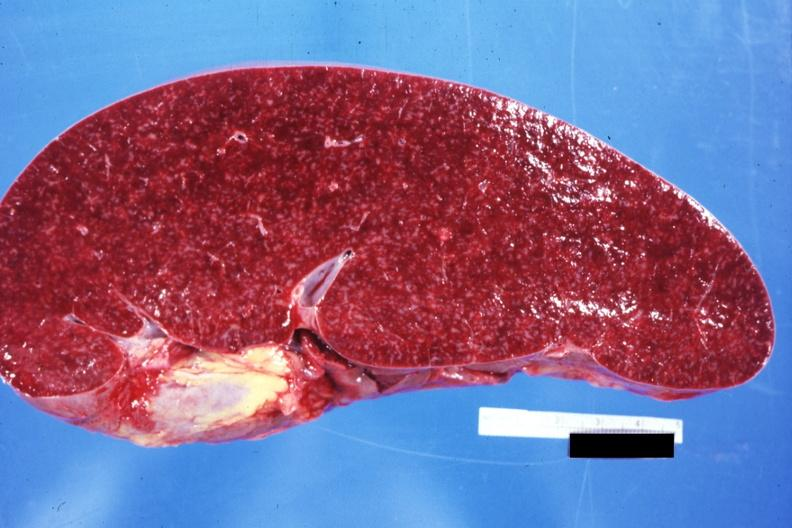what does normal see?
Answer the question using a single word or phrase. Other sides this case 